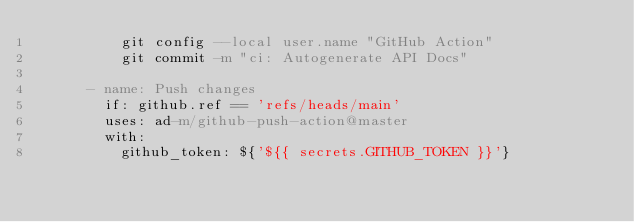Convert code to text. <code><loc_0><loc_0><loc_500><loc_500><_YAML_>          git config --local user.name "GitHub Action"
          git commit -m "ci: Autogenerate API Docs"

      - name: Push changes
        if: github.ref == 'refs/heads/main'
        uses: ad-m/github-push-action@master
        with:
          github_token: ${'${{ secrets.GITHUB_TOKEN }}'}
</code> 